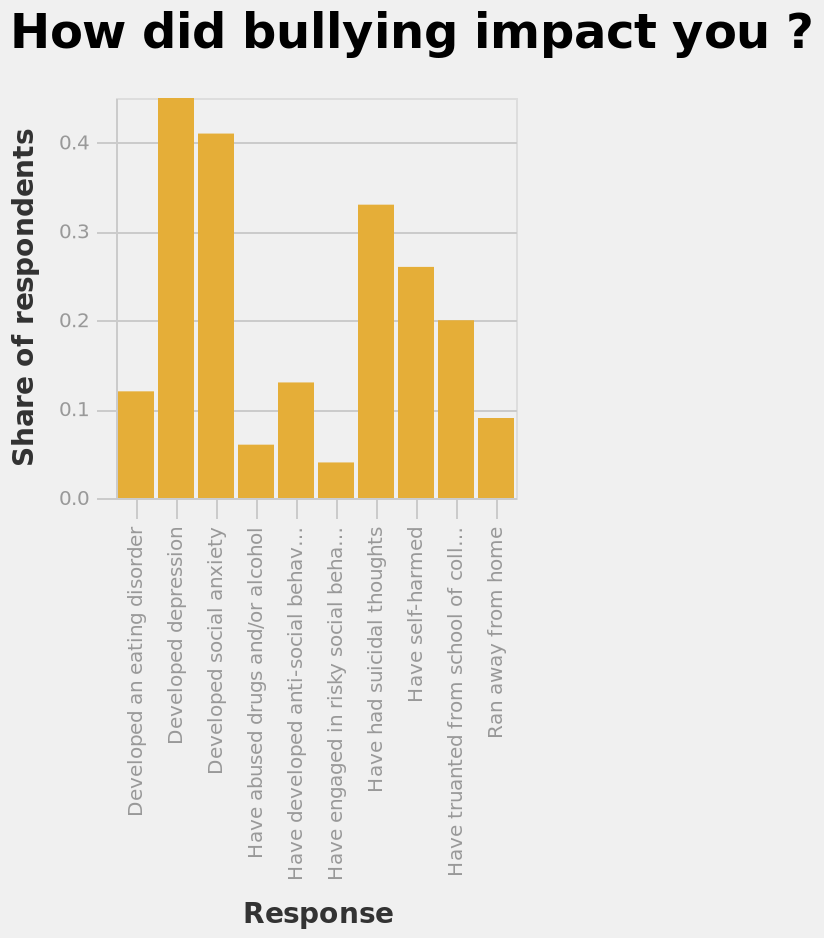<image>
What is the name of the bar graph?  The bar graph is named "How did bullying impact you?" please summary the statistics and relations of the chart The majority of respondents developed depression as an impact of bullying, closely followed by social anxiety. Which psychological condition closely followed depression as a result of being bullied according to the respondents?  Social anxiety 